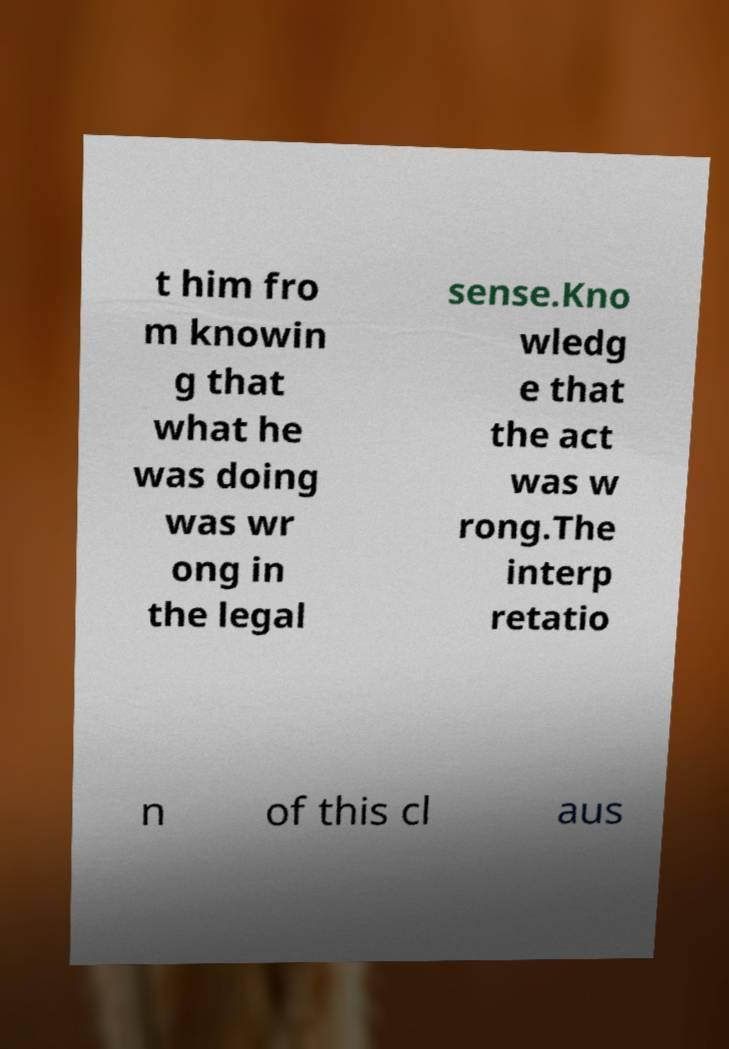Could you assist in decoding the text presented in this image and type it out clearly? t him fro m knowin g that what he was doing was wr ong in the legal sense.Kno wledg e that the act was w rong.The interp retatio n of this cl aus 